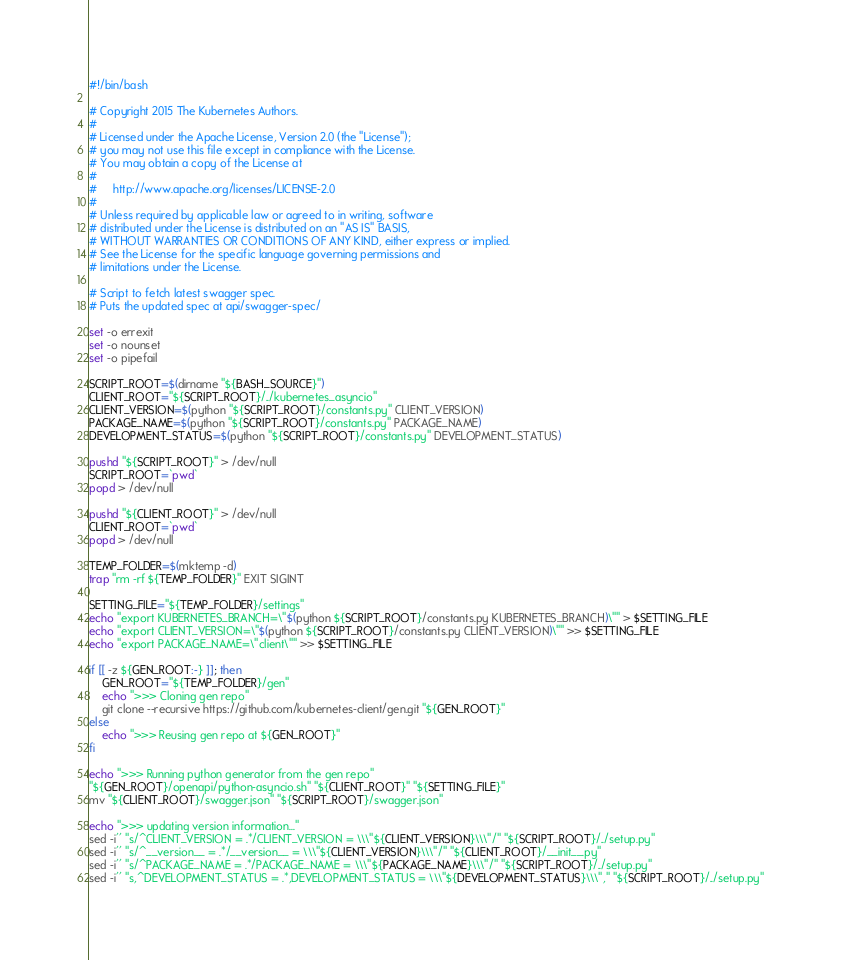Convert code to text. <code><loc_0><loc_0><loc_500><loc_500><_Bash_>#!/bin/bash

# Copyright 2015 The Kubernetes Authors.
#
# Licensed under the Apache License, Version 2.0 (the "License");
# you may not use this file except in compliance with the License.
# You may obtain a copy of the License at
#
#     http://www.apache.org/licenses/LICENSE-2.0
#
# Unless required by applicable law or agreed to in writing, software
# distributed under the License is distributed on an "AS IS" BASIS,
# WITHOUT WARRANTIES OR CONDITIONS OF ANY KIND, either express or implied.
# See the License for the specific language governing permissions and
# limitations under the License.

# Script to fetch latest swagger spec.
# Puts the updated spec at api/swagger-spec/

set -o errexit
set -o nounset
set -o pipefail

SCRIPT_ROOT=$(dirname "${BASH_SOURCE}")
CLIENT_ROOT="${SCRIPT_ROOT}/../kubernetes_asyncio"
CLIENT_VERSION=$(python "${SCRIPT_ROOT}/constants.py" CLIENT_VERSION)
PACKAGE_NAME=$(python "${SCRIPT_ROOT}/constants.py" PACKAGE_NAME)
DEVELOPMENT_STATUS=$(python "${SCRIPT_ROOT}/constants.py" DEVELOPMENT_STATUS)

pushd "${SCRIPT_ROOT}" > /dev/null
SCRIPT_ROOT=`pwd`
popd > /dev/null

pushd "${CLIENT_ROOT}" > /dev/null
CLIENT_ROOT=`pwd`
popd > /dev/null

TEMP_FOLDER=$(mktemp -d) 
trap "rm -rf ${TEMP_FOLDER}" EXIT SIGINT

SETTING_FILE="${TEMP_FOLDER}/settings"
echo "export KUBERNETES_BRANCH=\"$(python ${SCRIPT_ROOT}/constants.py KUBERNETES_BRANCH)\"" > $SETTING_FILE
echo "export CLIENT_VERSION=\"$(python ${SCRIPT_ROOT}/constants.py CLIENT_VERSION)\"" >> $SETTING_FILE
echo "export PACKAGE_NAME=\"client\"" >> $SETTING_FILE

if [[ -z ${GEN_ROOT:-} ]]; then
    GEN_ROOT="${TEMP_FOLDER}/gen"
    echo ">>> Cloning gen repo"
    git clone --recursive https://github.com/kubernetes-client/gen.git "${GEN_ROOT}"
else
    echo ">>> Reusing gen repo at ${GEN_ROOT}"
fi

echo ">>> Running python generator from the gen repo"
"${GEN_ROOT}/openapi/python-asyncio.sh" "${CLIENT_ROOT}" "${SETTING_FILE}"
mv "${CLIENT_ROOT}/swagger.json" "${SCRIPT_ROOT}/swagger.json"

echo ">>> updating version information..."
sed -i'' "s/^CLIENT_VERSION = .*/CLIENT_VERSION = \\\"${CLIENT_VERSION}\\\"/" "${SCRIPT_ROOT}/../setup.py"
sed -i'' "s/^__version__ = .*/__version__ = \\\"${CLIENT_VERSION}\\\"/" "${CLIENT_ROOT}/__init__.py"
sed -i'' "s/^PACKAGE_NAME = .*/PACKAGE_NAME = \\\"${PACKAGE_NAME}\\\"/" "${SCRIPT_ROOT}/../setup.py"
sed -i'' "s,^DEVELOPMENT_STATUS = .*,DEVELOPMENT_STATUS = \\\"${DEVELOPMENT_STATUS}\\\"," "${SCRIPT_ROOT}/../setup.py"
</code> 